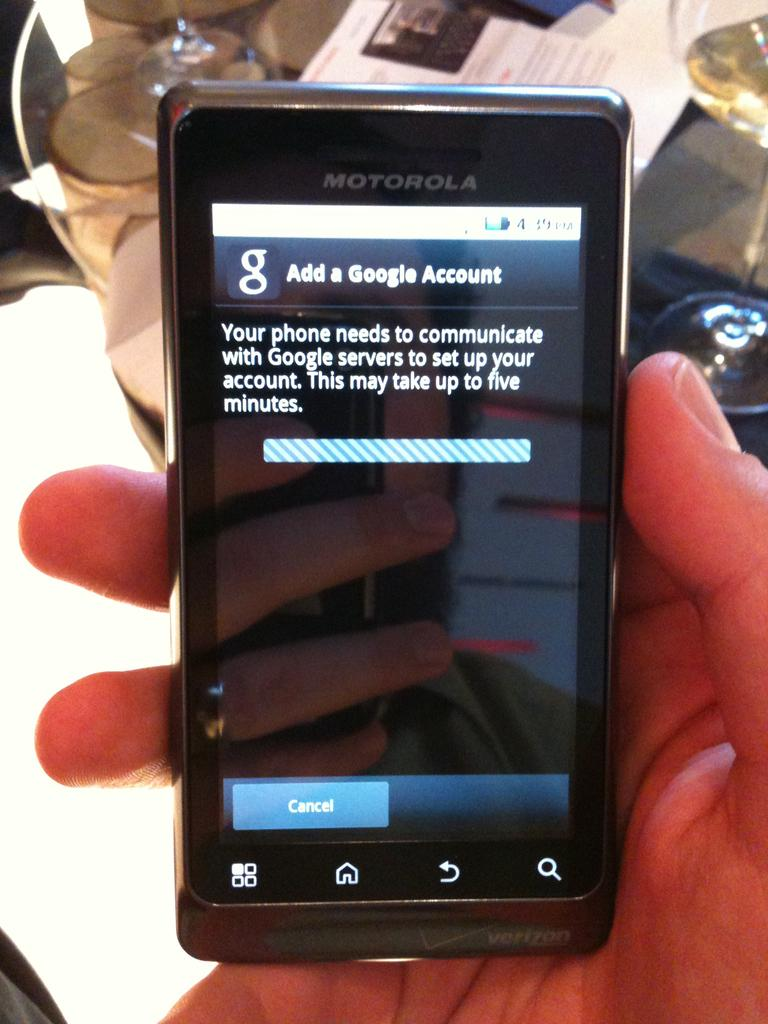<image>
Share a concise interpretation of the image provided. A Motorola touch screen cell phone bares a message telling the user the add a google account. 